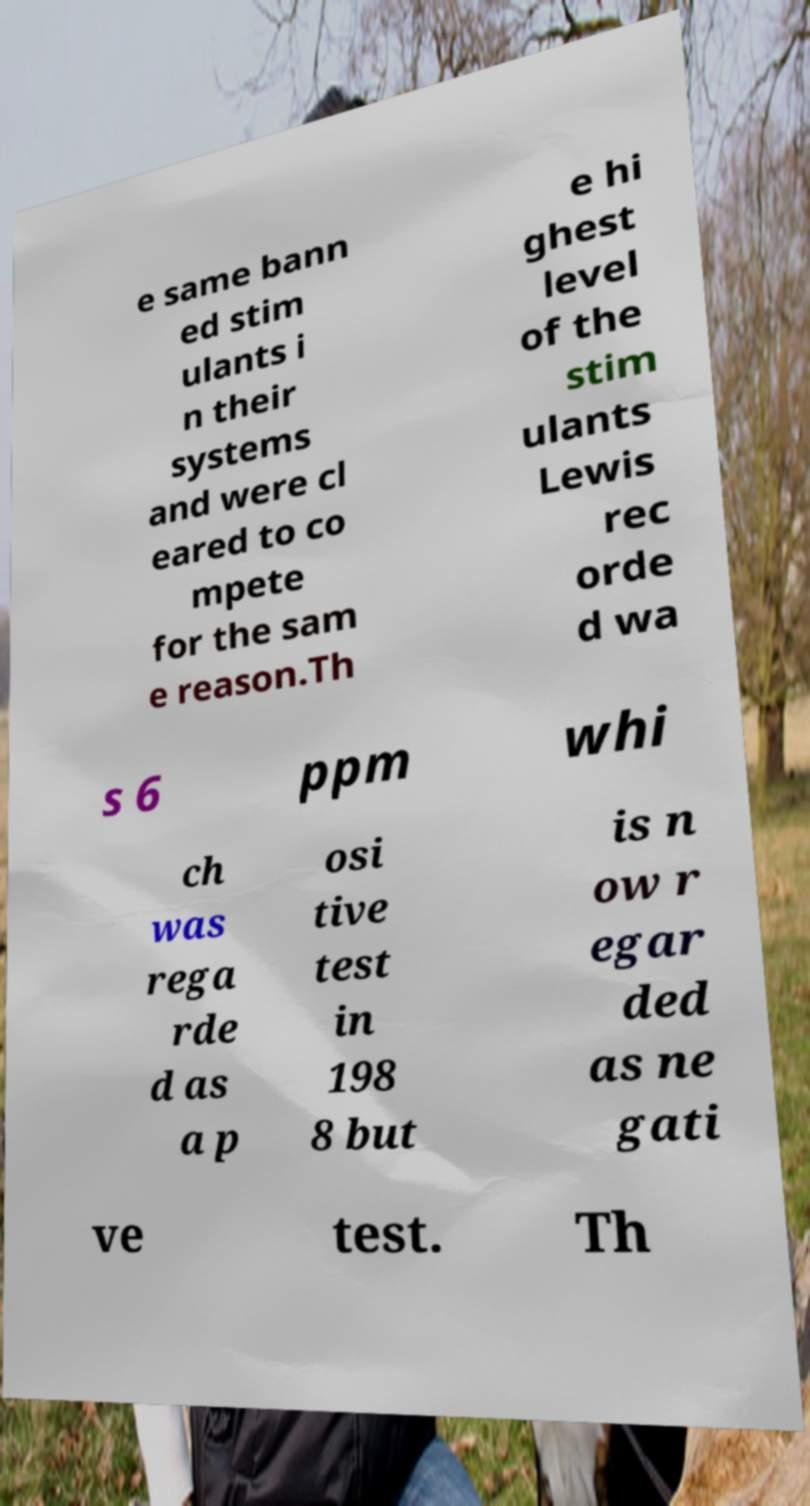Can you accurately transcribe the text from the provided image for me? e same bann ed stim ulants i n their systems and were cl eared to co mpete for the sam e reason.Th e hi ghest level of the stim ulants Lewis rec orde d wa s 6 ppm whi ch was rega rde d as a p osi tive test in 198 8 but is n ow r egar ded as ne gati ve test. Th 